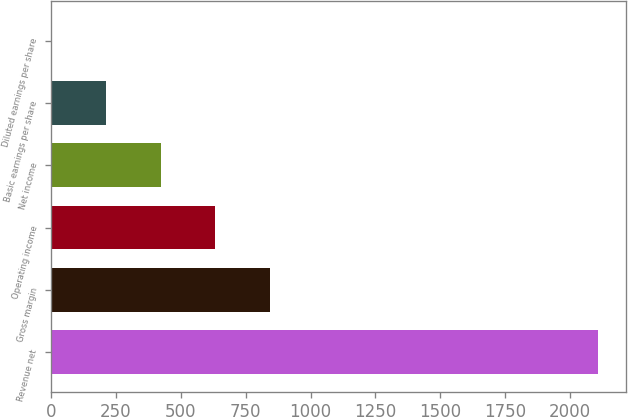Convert chart. <chart><loc_0><loc_0><loc_500><loc_500><bar_chart><fcel>Revenue net<fcel>Gross margin<fcel>Operating income<fcel>Net income<fcel>Basic earnings per share<fcel>Diluted earnings per share<nl><fcel>2109<fcel>844.17<fcel>633.36<fcel>422.55<fcel>211.74<fcel>0.93<nl></chart> 